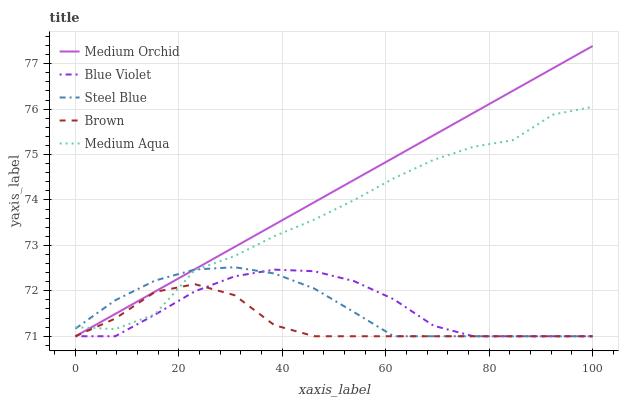Does Brown have the minimum area under the curve?
Answer yes or no. Yes. Does Medium Orchid have the maximum area under the curve?
Answer yes or no. Yes. Does Medium Aqua have the minimum area under the curve?
Answer yes or no. No. Does Medium Aqua have the maximum area under the curve?
Answer yes or no. No. Is Medium Orchid the smoothest?
Answer yes or no. Yes. Is Medium Aqua the roughest?
Answer yes or no. Yes. Is Medium Aqua the smoothest?
Answer yes or no. No. Is Medium Orchid the roughest?
Answer yes or no. No. Does Brown have the lowest value?
Answer yes or no. Yes. Does Medium Aqua have the lowest value?
Answer yes or no. No. Does Medium Orchid have the highest value?
Answer yes or no. Yes. Does Medium Aqua have the highest value?
Answer yes or no. No. Is Blue Violet less than Medium Aqua?
Answer yes or no. Yes. Is Medium Aqua greater than Blue Violet?
Answer yes or no. Yes. Does Brown intersect Steel Blue?
Answer yes or no. Yes. Is Brown less than Steel Blue?
Answer yes or no. No. Is Brown greater than Steel Blue?
Answer yes or no. No. Does Blue Violet intersect Medium Aqua?
Answer yes or no. No. 